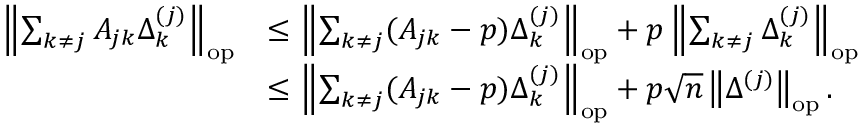<formula> <loc_0><loc_0><loc_500><loc_500>\begin{array} { r l } { \left \| { \sum _ { k \neq j } A _ { j k } \Delta _ { k } ^ { ( j ) } } \right \| _ { o p } } & { \leq \left \| { \sum _ { k \neq j } ( A _ { j k } - p ) \Delta _ { k } ^ { ( j ) } } \right \| _ { o p } + p \left \| { \sum _ { k \neq j } \Delta _ { k } ^ { ( j ) } } \right \| _ { o p } } \\ & { \leq \left \| { \sum _ { k \neq j } ( A _ { j k } - p ) \Delta _ { k } ^ { ( j ) } } \right \| _ { o p } + p \sqrt { n } \left \| { \Delta ^ { ( j ) } } \right \| _ { o p } . } \end{array}</formula> 